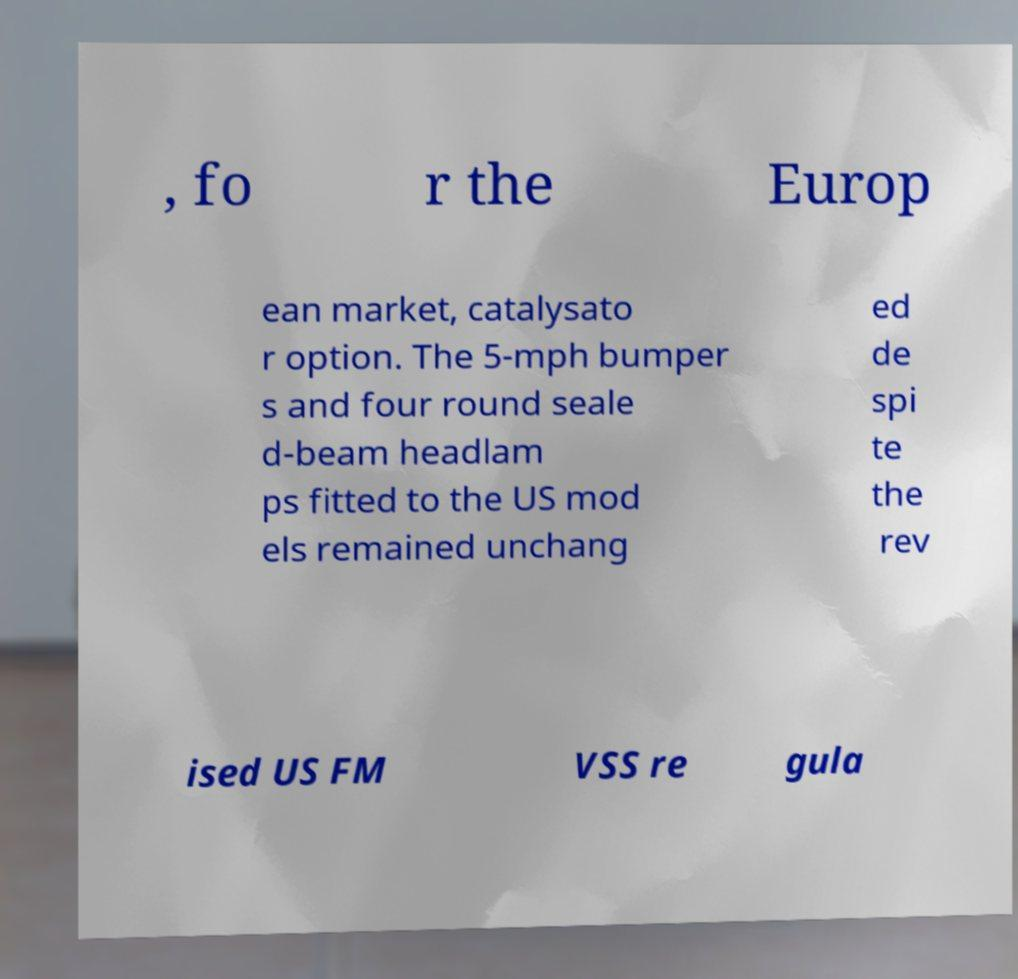Can you accurately transcribe the text from the provided image for me? , fo r the Europ ean market, catalysato r option. The 5-mph bumper s and four round seale d-beam headlam ps fitted to the US mod els remained unchang ed de spi te the rev ised US FM VSS re gula 